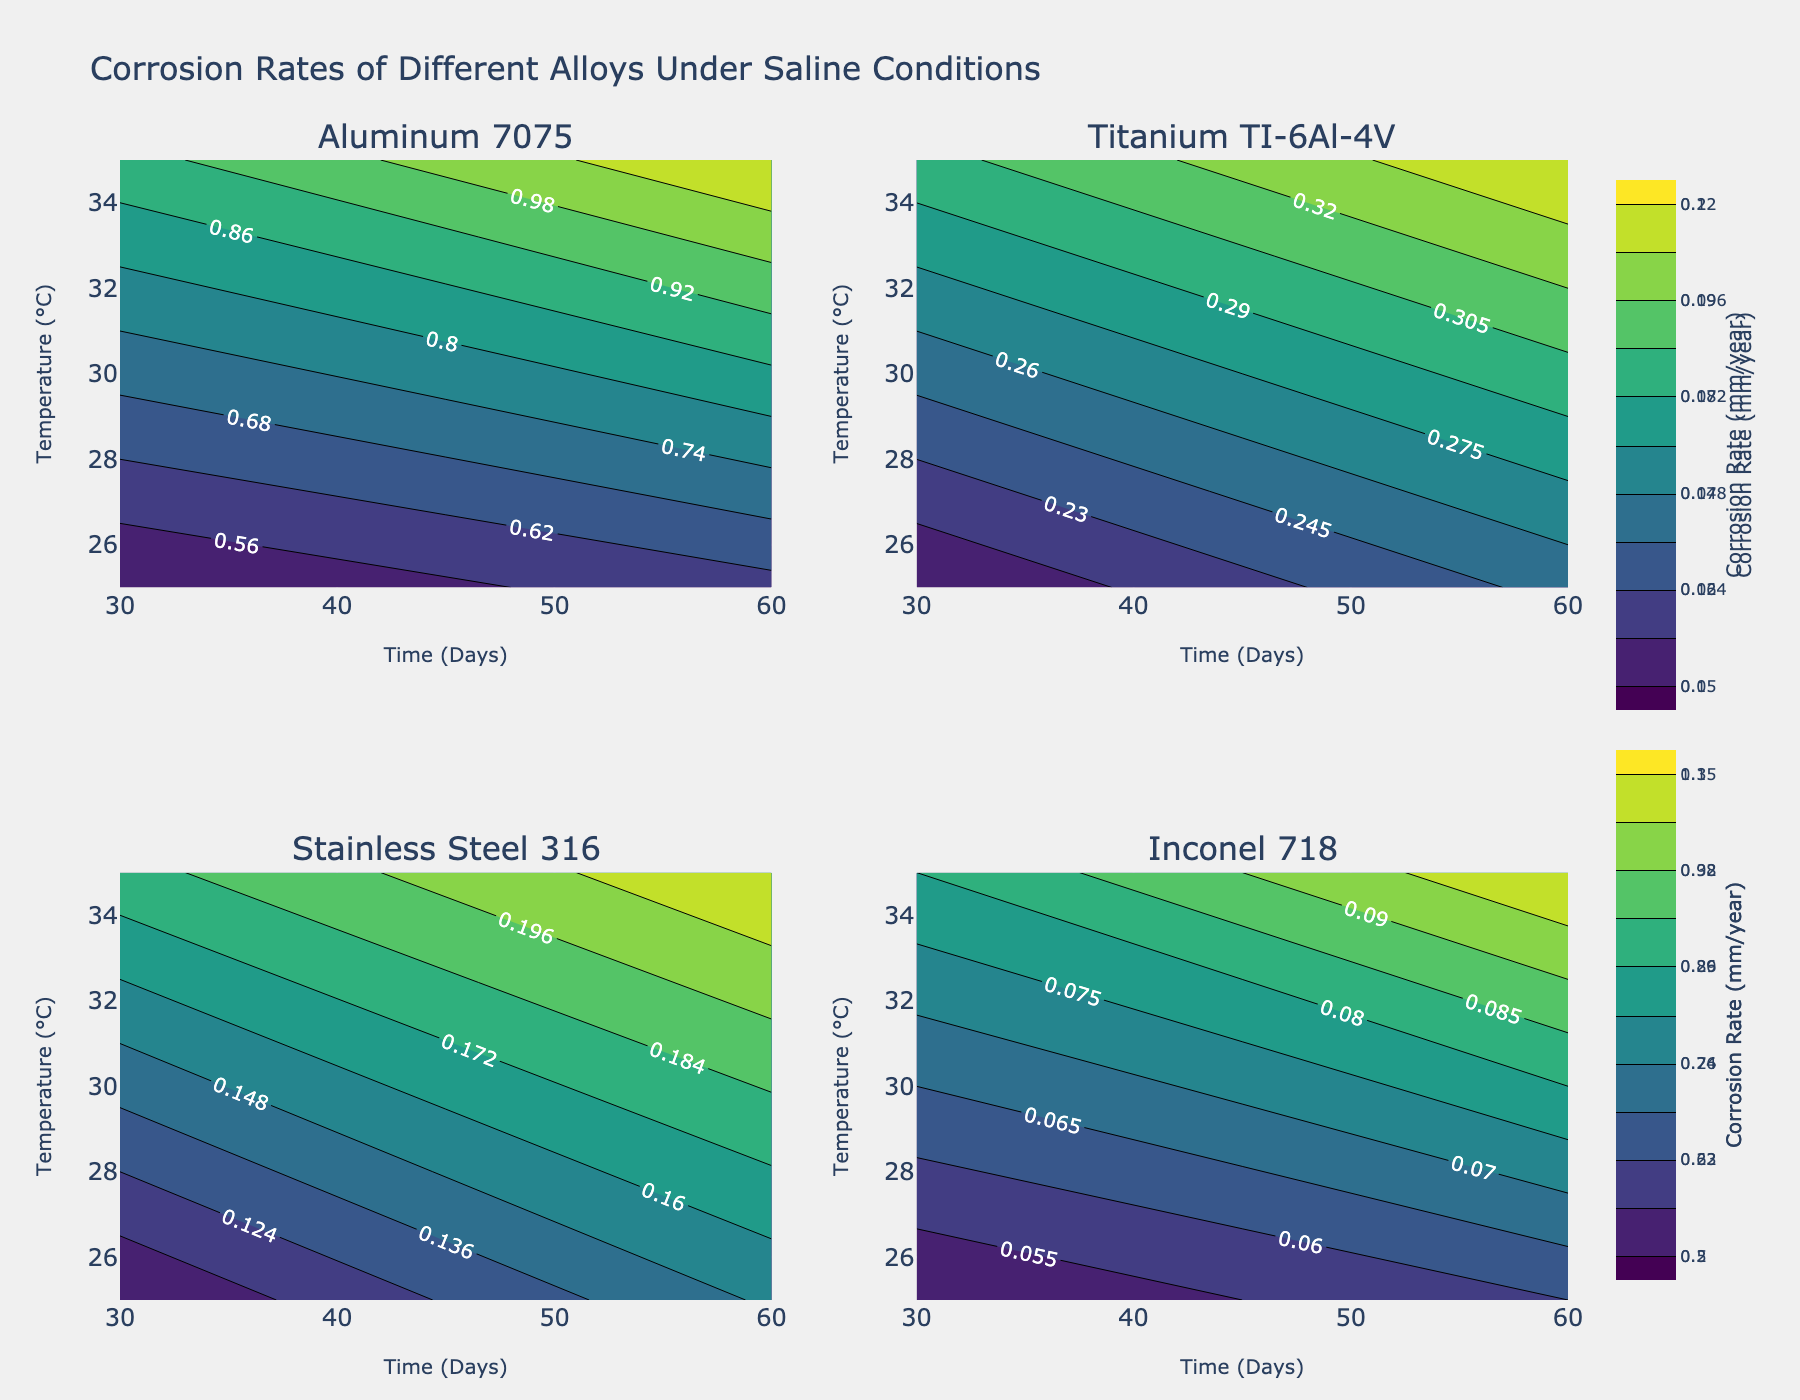What is the material with the highest corrosion rate under 35°C after 60 days? By examining the subplots, you can identify that the highest corrosion rate under 35°C after 60 days occurs with Aluminum 7075.
Answer: Aluminum 7075 Which material shows the lowest overall corrosion rate in both temperatures and times? Reviewing the subplots, it is clear that Inconel 718 consistently shows the lowest corrosion rate across both temperatures (25°C and 35°C) and times (30 days and 60 days).
Answer: Inconel 718 How does the corrosion rate of Titanium TI-6Al-4V change from 30 days to 60 days at 25°C? For the Titanium TI-6Al-4V subplot, compare the corrosion rates recorded at 25°C for 30 and 60 days. The rate increases from 0.2 mm/year to 0.25 mm/year.
Answer: It increases from 0.2 mm/year to 0.25 mm/year Which material shows the most significant increase in corrosion rate when the temperature goes from 25°C to 35°C after 30 days? When comparing corrosion rates at 30 days between 25°C and 35°C, Aluminum 7075 shows the most significant increase from 0.5 mm/year to 0.9 mm/year.
Answer: Aluminum 7075 At 35°C and 60 days, rank the materials from the highest to the lowest corrosion rate. By analyzing the subplots, the ranking at 35°C and 60 days is as follows: Aluminum 7075 (1.1 mm/year), Titanium TI-6Al-4V (0.35 mm/year), Stainless Steel 316 (0.22 mm/year), Inconel 718 (0.1 mm/year).
Answer: Aluminum 7075, Titanium TI-6Al-4V, Stainless Steel 316, Inconel 718 Which subplot illustrates the corrosion rate data for Stainless Steel 316? Locate the subplot titled 'Stainless Steel 316'; it contains the corrosion rate data for this material.
Answer: The subplot titled 'Stainless Steel 316' Does any material show a trend where the corrosion rate decreases with time under the same temperature? Observing the subplots, none of the materials demonstrate a decreasing corrosion rate with increasing time under the same temperature.
Answer: No What is the corrosion rate of Stainless Steel 316 at 25°C and 30 days? On the Stainless Steel 316 subplot, identify the corrosion rate at 25°C and 30 days. It is marked as 0.1 mm/year.
Answer: 0.1 mm/year What are the contour line interval sizes for each material? Each contour plot uses an interval size to display the rate gradients. For Aluminum 7075, it's (1.1-0.5)/10=0.06 mm/year. For Titanium TI-6Al-4V, it's (0.35-0.2)/10=0.015 mm/year. For Stainless Steel 316, it's (0.22-0.1)/10=0.012 mm/year. For Inconel 718, it's (0.1-0.05)/10=0.005 mm/year.
Answer: Aluminum 7075: 0.06 mm/year, Titanium TI-6Al-4V: 0.015 mm/year, Stainless Steel 316: 0.012 mm/year, Inconel 718: 0.005 mm/year 